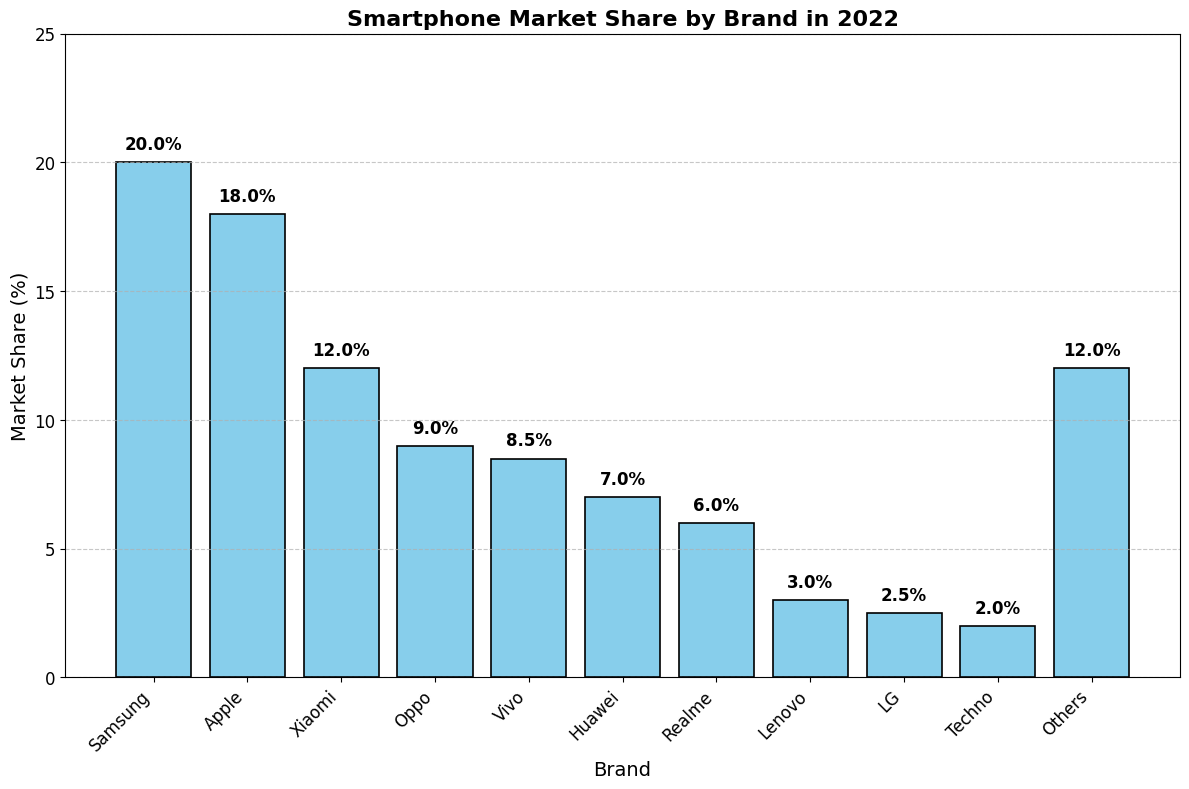Which brand has the highest market share? The highest bar in the chart, representing the brand with the highest market share, is Samsung.
Answer: Samsung What is the difference in market share between Samsung and Apple? Samsung has a market share of 20%, and Apple has a market share of 18%. The difference is calculated as 20% - 18% = 2%.
Answer: 2% Which brand has a market share less than 5%? The bars representing brands with market shares less than 5% are Lenovo (3.0%), LG (2.5%), and Techno (2.0%).
Answer: Lenovo, LG, Techno What's the combined market share of brands with shares less than 8%? Adding the market shares of Oppo (9.0%), Vivo (8.5%), Huawei (7.0%), Realme (6.0%), Lenovo (3.0%), LG (2.5%), Techno (2.0%), and Others (12.0%) gives 45.0%.
Answer: 45.0% Which brand is ranked third in market share? The third highest bar in the chart represents Xiaomi with a market share of 12%.
Answer: Xiaomi What percentage of the market is occupied by brands other than Samsung, Apple, and Xiaomi? The total market share of Samsung, Apple, and Xiaomi is 20% + 18% + 12% = 50%. Subtracting this from 100% gives 100% - 50% = 50%.
Answer: 50% Is the market share of Vivo greater than Huawei? The bar representing Vivo (8.5%) is higher than the bar representing Huawei (7.0%), indicating that Vivo has a greater market share than Huawei.
Answer: Yes Which brands have market shares between 5% and 10%? The bars representing these brands are Oppo (9.0%), Vivo (8.5%), Huawei (7.0%), and Realme (6.0%).
Answer: Oppo, Vivo, Huawei, Realme What is the total market share of the top four brands? The top four brands by market share are Samsung (20.0%), Apple (18.0%), Xiaomi (12.0%), and Oppo (9.0%). Summing these values gives 20.0% + 18.0% + 12.0% + 9.0% = 59.0%.
Answer: 59.0% 